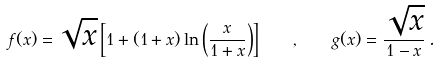<formula> <loc_0><loc_0><loc_500><loc_500>f ( x ) = \sqrt { x } \left [ 1 + ( 1 + x ) \ln \left ( \frac { x } { 1 + x } \right ) \right ] \quad , \quad g ( x ) = \frac { \sqrt { x } } { 1 - x } \, .</formula> 